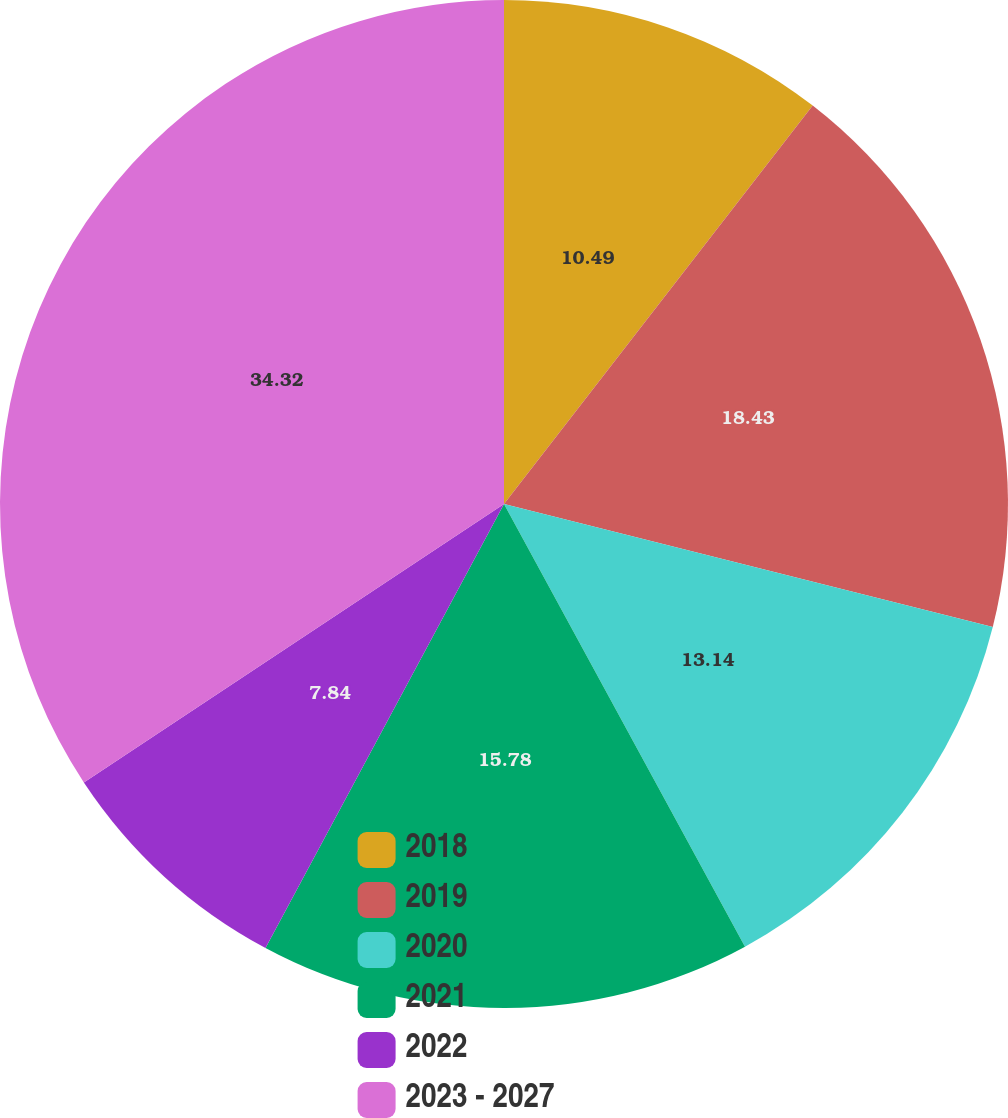<chart> <loc_0><loc_0><loc_500><loc_500><pie_chart><fcel>2018<fcel>2019<fcel>2020<fcel>2021<fcel>2022<fcel>2023 - 2027<nl><fcel>10.49%<fcel>18.43%<fcel>13.14%<fcel>15.78%<fcel>7.84%<fcel>34.31%<nl></chart> 